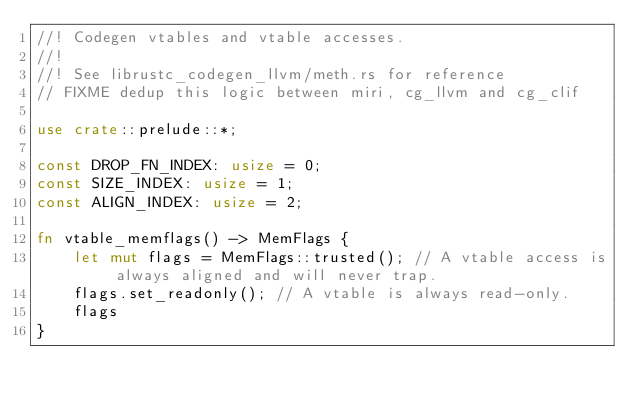<code> <loc_0><loc_0><loc_500><loc_500><_Rust_>//! Codegen vtables and vtable accesses.
//!
//! See librustc_codegen_llvm/meth.rs for reference
// FIXME dedup this logic between miri, cg_llvm and cg_clif

use crate::prelude::*;

const DROP_FN_INDEX: usize = 0;
const SIZE_INDEX: usize = 1;
const ALIGN_INDEX: usize = 2;

fn vtable_memflags() -> MemFlags {
    let mut flags = MemFlags::trusted(); // A vtable access is always aligned and will never trap.
    flags.set_readonly(); // A vtable is always read-only.
    flags
}
</code> 